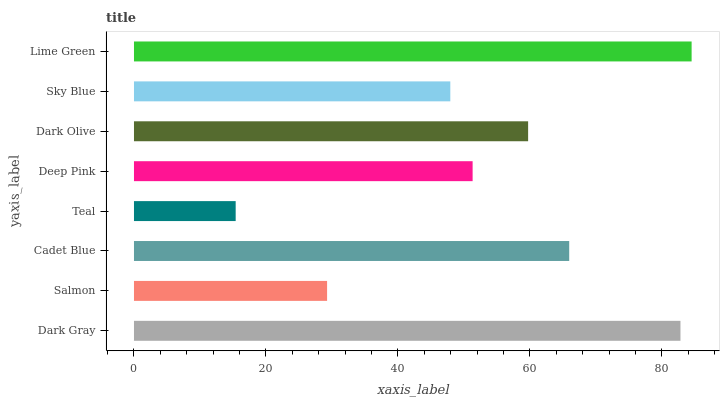Is Teal the minimum?
Answer yes or no. Yes. Is Lime Green the maximum?
Answer yes or no. Yes. Is Salmon the minimum?
Answer yes or no. No. Is Salmon the maximum?
Answer yes or no. No. Is Dark Gray greater than Salmon?
Answer yes or no. Yes. Is Salmon less than Dark Gray?
Answer yes or no. Yes. Is Salmon greater than Dark Gray?
Answer yes or no. No. Is Dark Gray less than Salmon?
Answer yes or no. No. Is Dark Olive the high median?
Answer yes or no. Yes. Is Deep Pink the low median?
Answer yes or no. Yes. Is Sky Blue the high median?
Answer yes or no. No. Is Sky Blue the low median?
Answer yes or no. No. 